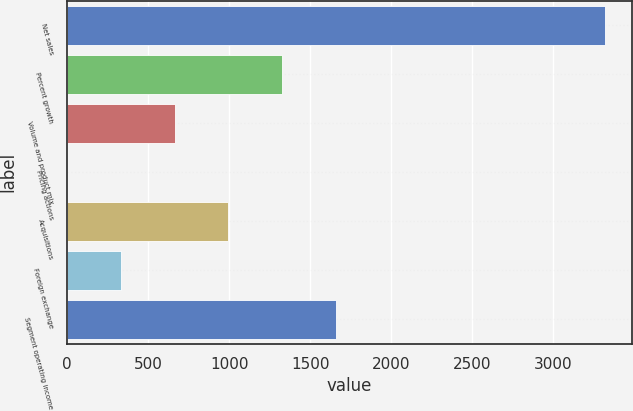Convert chart. <chart><loc_0><loc_0><loc_500><loc_500><bar_chart><fcel>Net sales<fcel>Percent growth<fcel>Volume and product mix<fcel>Pricing actions<fcel>Acquisitions<fcel>Foreign exchange<fcel>Segment operating income<nl><fcel>3318<fcel>1327.56<fcel>664.08<fcel>0.6<fcel>995.82<fcel>332.34<fcel>1659.3<nl></chart> 